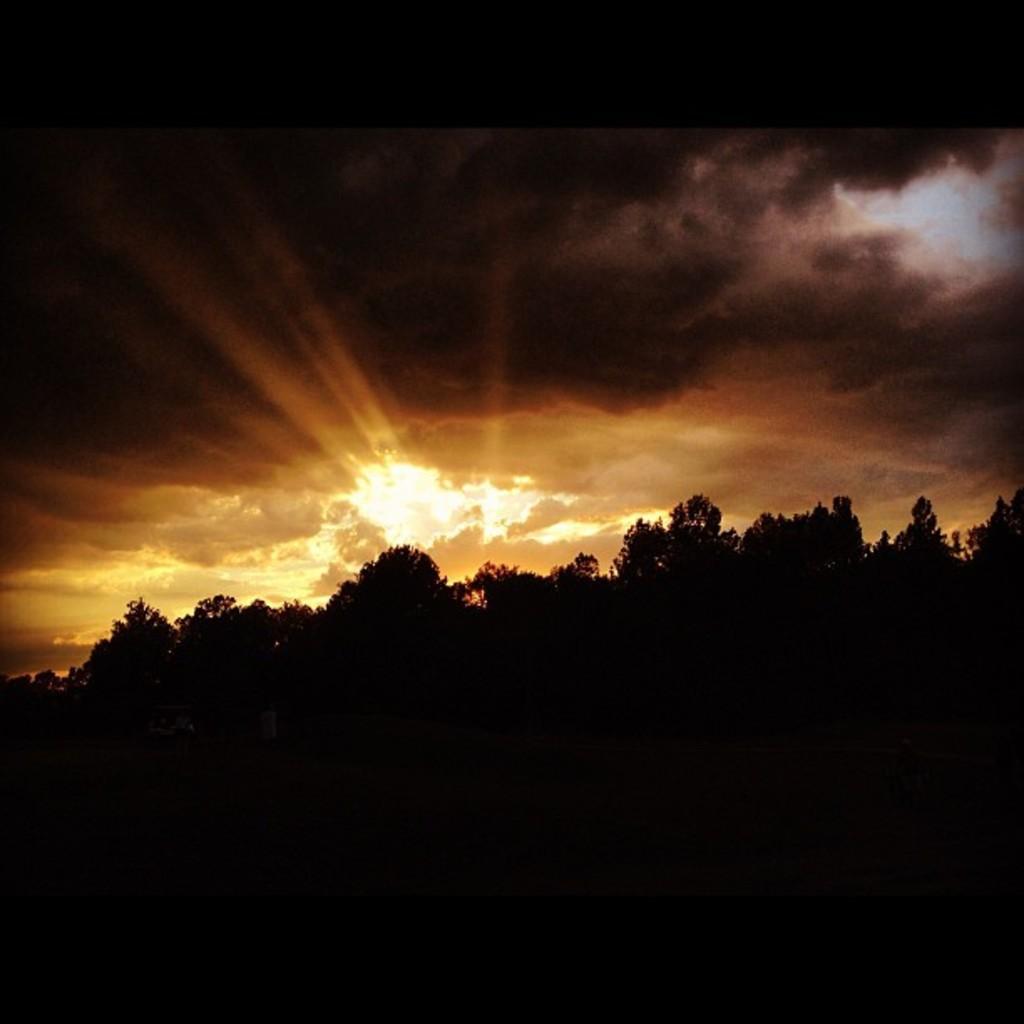In one or two sentences, can you explain what this image depicts? This picture is dark, in this picture we can see trees and sky with clouds. 